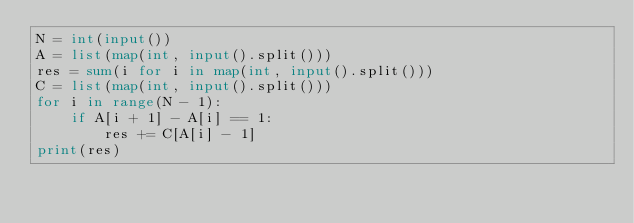<code> <loc_0><loc_0><loc_500><loc_500><_Python_>N = int(input())
A = list(map(int, input().split()))
res = sum(i for i in map(int, input().split()))
C = list(map(int, input().split()))
for i in range(N - 1):
    if A[i + 1] - A[i] == 1:
        res += C[A[i] - 1]
print(res)</code> 